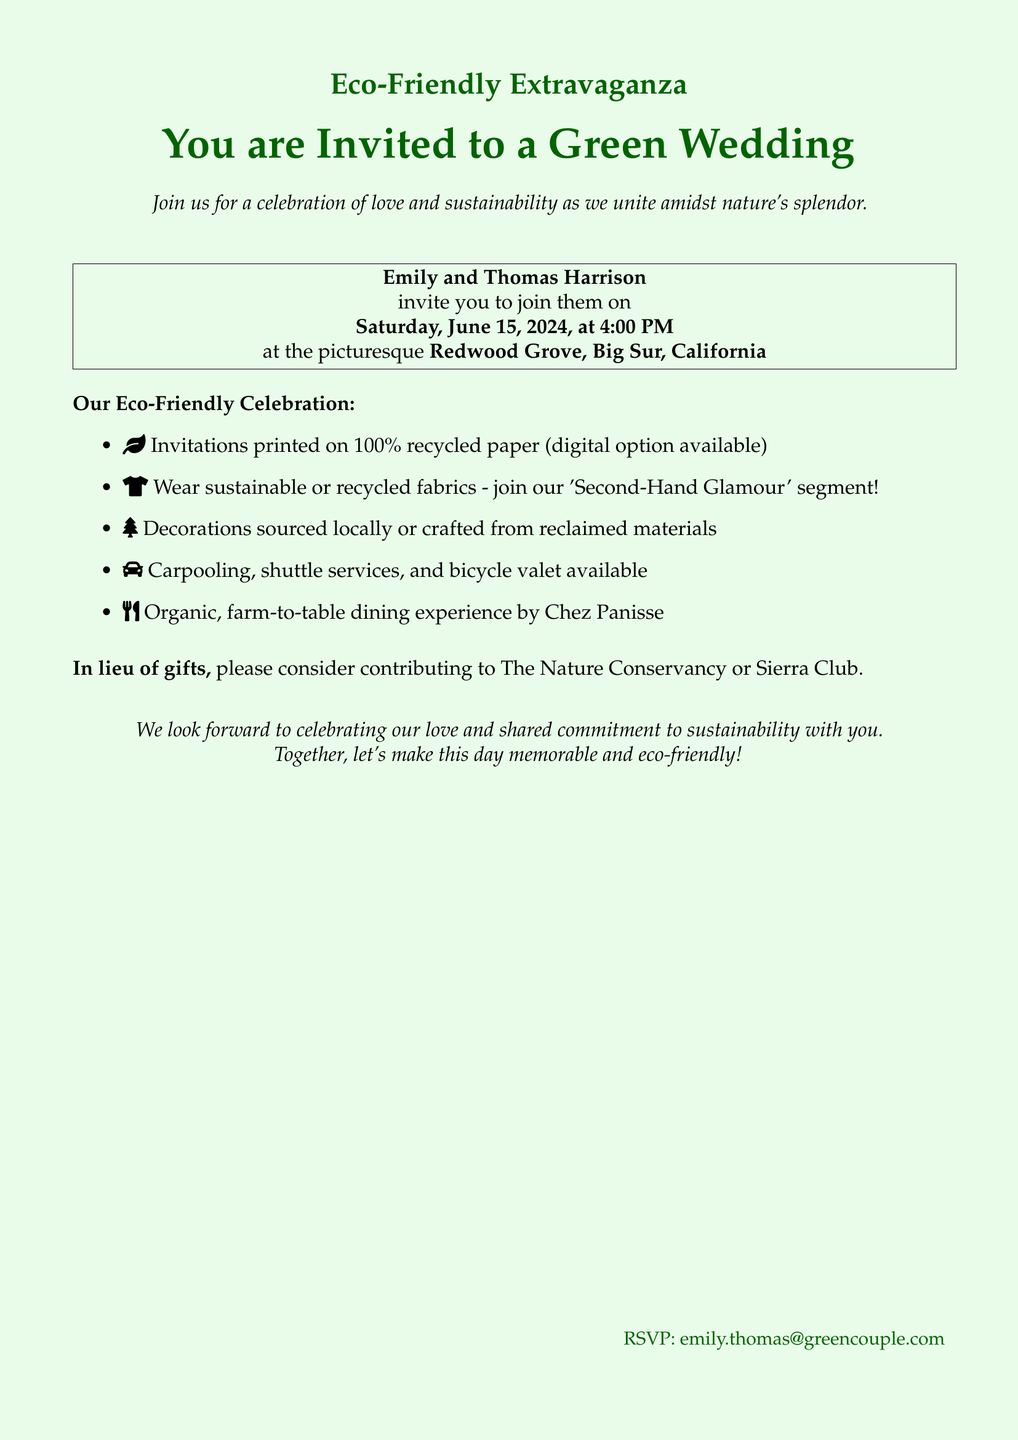What is the occasion for the invitation? The document is an invitation for a wedding celebration.
Answer: Wedding Who are getting married? The names of the couple getting married are mentioned in the document.
Answer: Emily and Thomas Harrison What date is the wedding taking place? The exact date of the event is stated in the invitation.
Answer: Saturday, June 15, 2024 Where is the wedding venue? The document specifies the location of the wedding.
Answer: Redwood Grove, Big Sur, California What type of paper are the invitations printed on? The material of the invitations is detailed in the celebration description.
Answer: 100% recycled paper What dining experience will be provided? The document describes the type of dining experience guests can expect.
Answer: Organic, farm-to-table dining What is the theme of the wedding celebration? The overall theme of the wedding is outlined in the title and body of the invitation.
Answer: Eco-Friendly What is encouraged for guests' attire? The invitation mentions specific clothing options for guests to consider.
Answer: Sustainable or recycled fabrics Who should RSVPs be sent to? The document provides a contact email for RSVPs.
Answer: emily.thomas@greencouple.com 